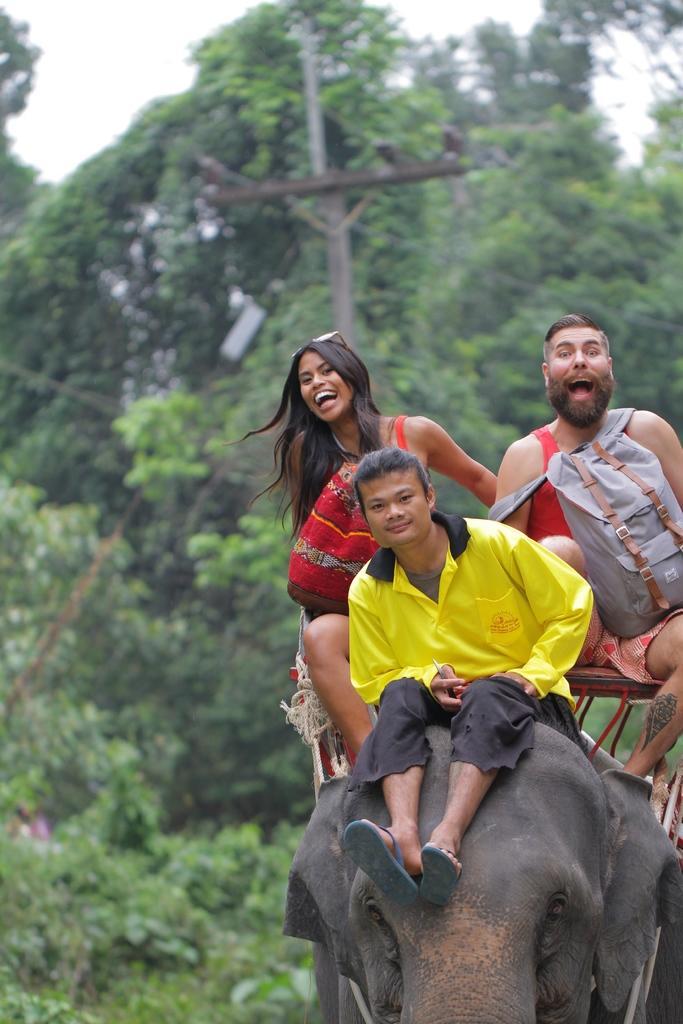Could you give a brief overview of what you see in this image? This 3 persons are sitting on a elephant. Far there are number of trees and pole. This person is carrying a bag. 